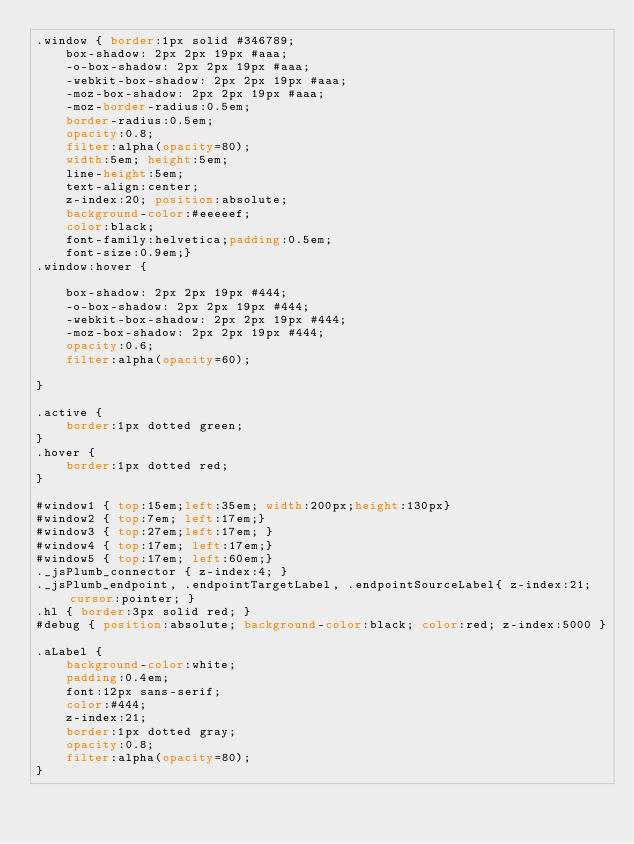Convert code to text. <code><loc_0><loc_0><loc_500><loc_500><_CSS_>.window { border:1px solid #346789;
    box-shadow: 2px 2px 19px #aaa;
    -o-box-shadow: 2px 2px 19px #aaa;
    -webkit-box-shadow: 2px 2px 19px #aaa;
    -moz-box-shadow: 2px 2px 19px #aaa;
    -moz-border-radius:0.5em;
    border-radius:0.5em;
    opacity:0.8;
    filter:alpha(opacity=80);
    width:5em; height:5em;
    line-height:5em;
    text-align:center;
    z-index:20; position:absolute;
    background-color:#eeeeef;
    color:black;
    font-family:helvetica;padding:0.5em;
    font-size:0.9em;}
.window:hover {

    box-shadow: 2px 2px 19px #444;
    -o-box-shadow: 2px 2px 19px #444;
    -webkit-box-shadow: 2px 2px 19px #444;
    -moz-box-shadow: 2px 2px 19px #444;
    opacity:0.6;
    filter:alpha(opacity=60);

}

.active {
    border:1px dotted green;
}
.hover {
    border:1px dotted red;
}

#window1 { top:15em;left:35em; width:200px;height:130px}
#window2 { top:7em; left:17em;}
#window3 { top:27em;left:17em; }
#window4 { top:17em; left:17em;}
#window5 { top:17em; left:60em;}
._jsPlumb_connector { z-index:4; }
._jsPlumb_endpoint, .endpointTargetLabel, .endpointSourceLabel{ z-index:21;cursor:pointer; }
.hl { border:3px solid red; }
#debug { position:absolute; background-color:black; color:red; z-index:5000 }

.aLabel {
    background-color:white;
    padding:0.4em;
    font:12px sans-serif;
    color:#444;
    z-index:21;
    border:1px dotted gray;
    opacity:0.8;
    filter:alpha(opacity=80);
}</code> 